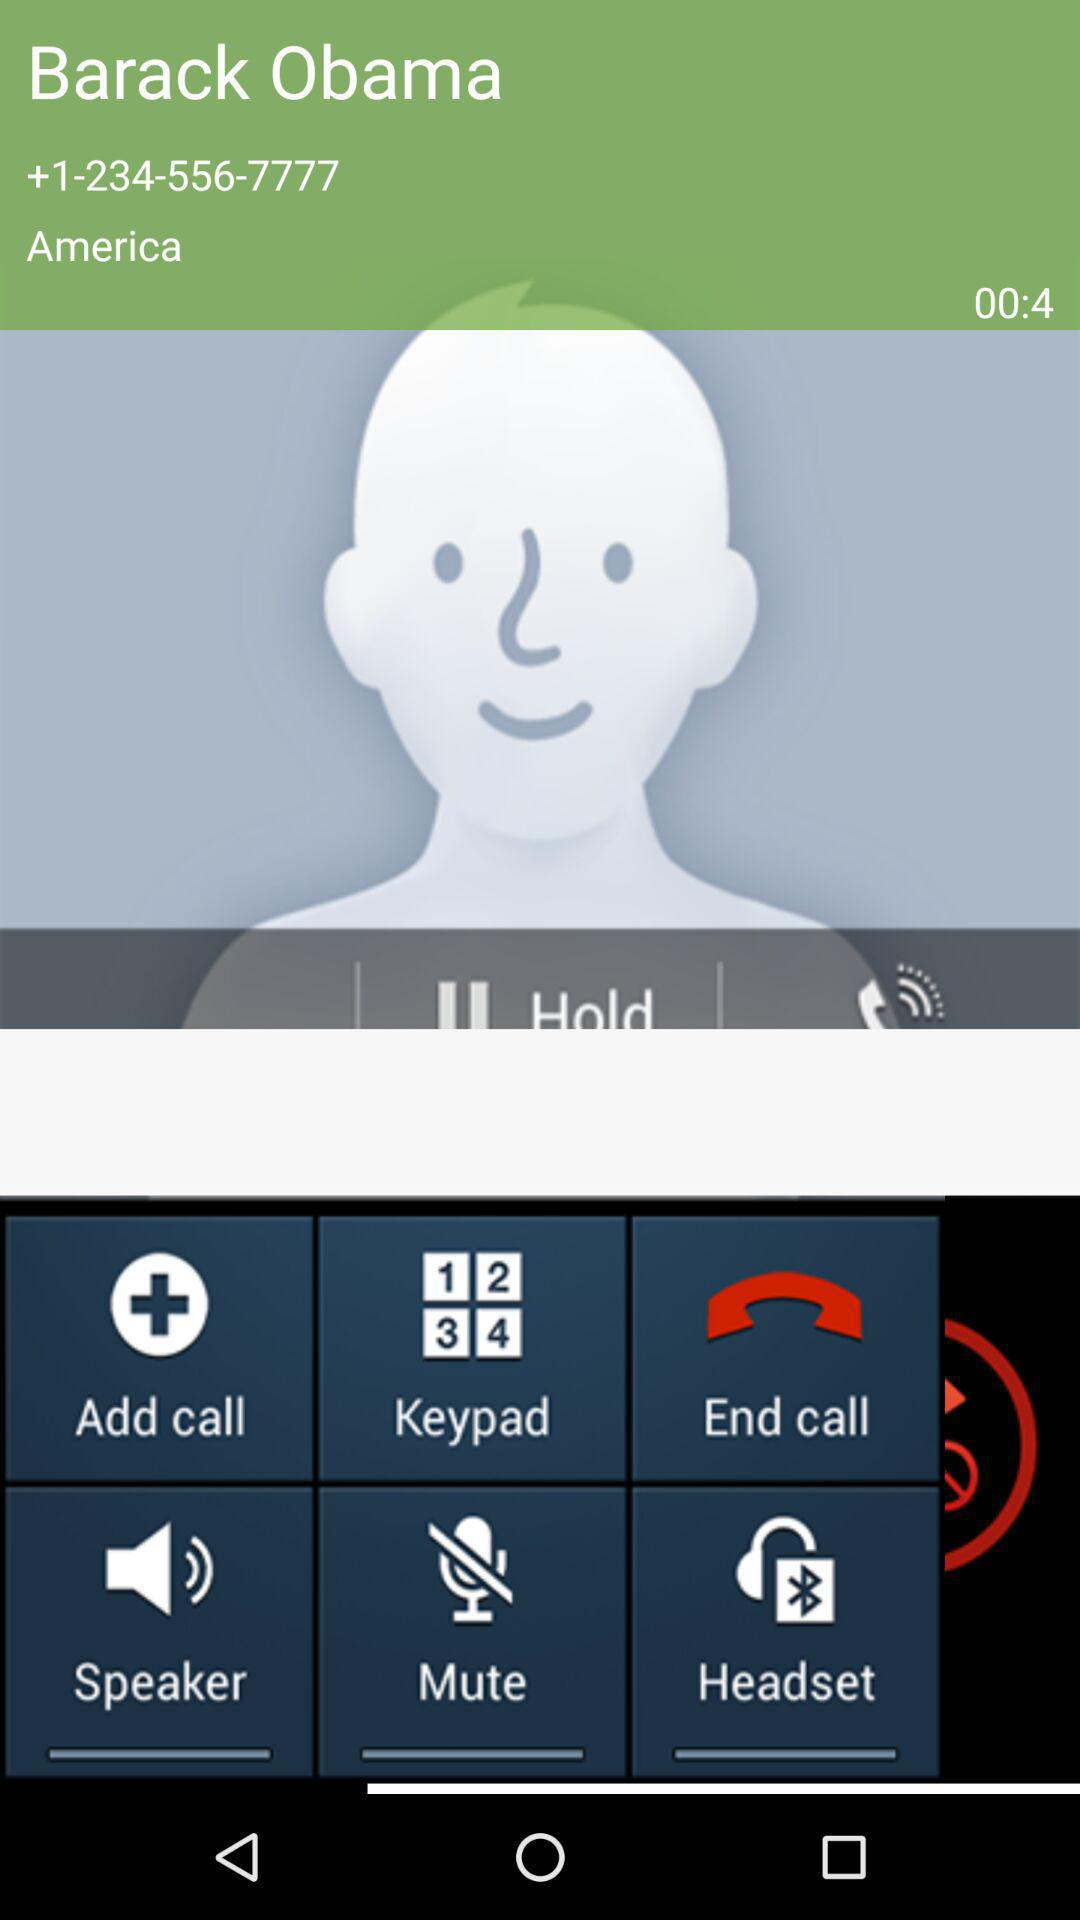How long is the current call duration? The current call duration is 4 seconds long. 